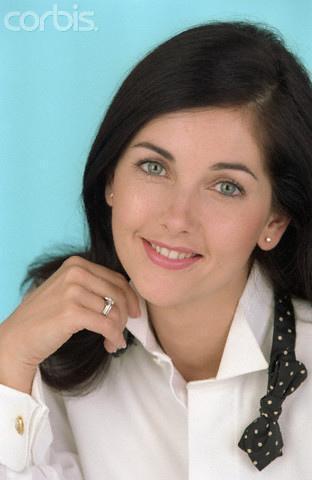How many people are in the picture?
Give a very brief answer. 1. How many bus windows are visible?
Give a very brief answer. 0. 